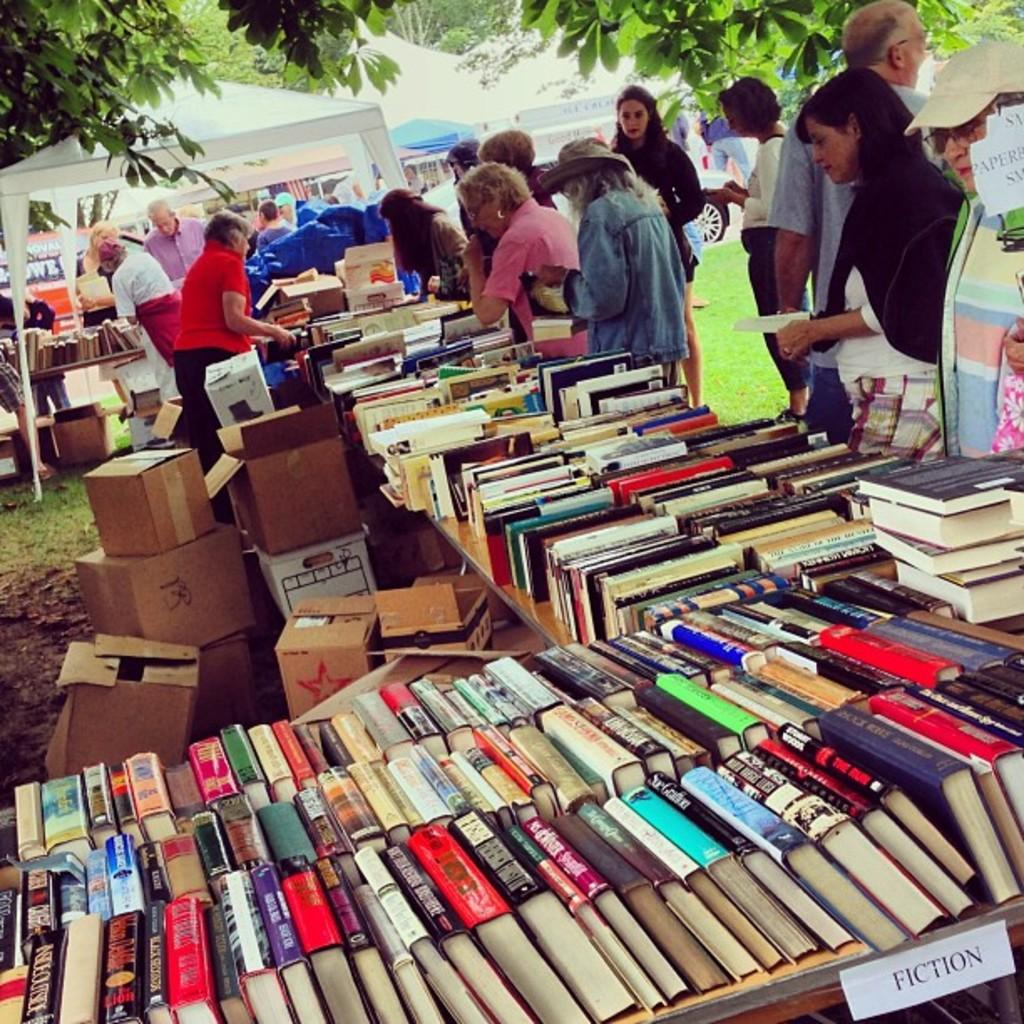<image>
Relay a brief, clear account of the picture shown. books on display at a yard sale are in the Fiction genre 